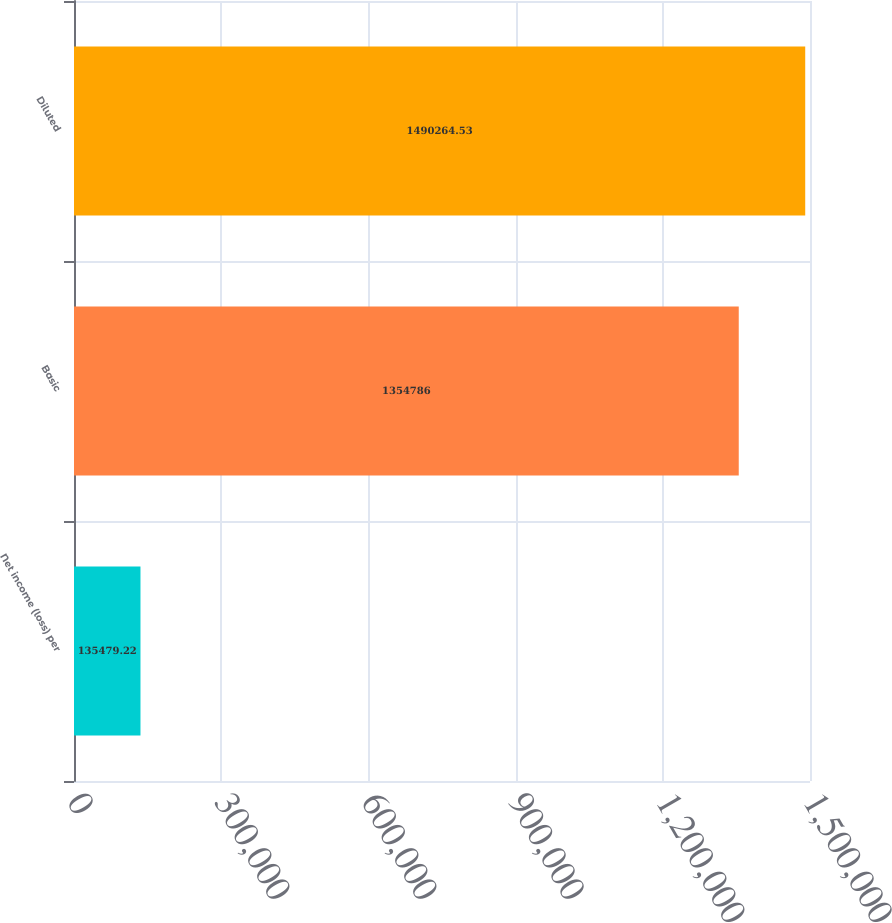Convert chart to OTSL. <chart><loc_0><loc_0><loc_500><loc_500><bar_chart><fcel>Net income (loss) per<fcel>Basic<fcel>Diluted<nl><fcel>135479<fcel>1.35479e+06<fcel>1.49026e+06<nl></chart> 